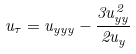<formula> <loc_0><loc_0><loc_500><loc_500>u _ { \tau } = u _ { y y y } - \frac { 3 u ^ { 2 } _ { y y } } { 2 u _ { y } }</formula> 